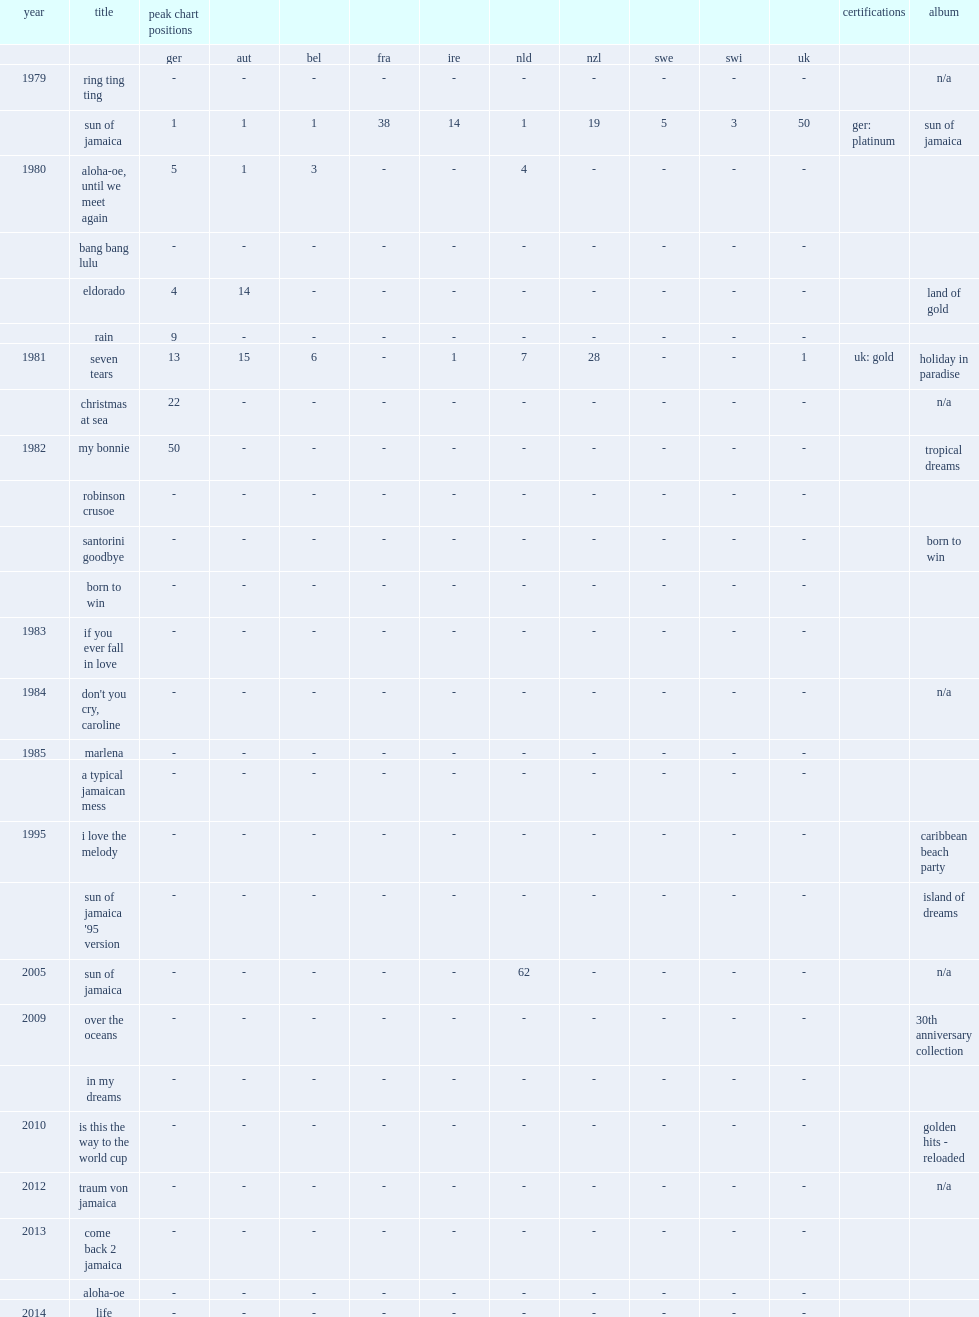In 1981, which album of goombay dance band released the album including single "seven tears"? Holiday in paradise. 